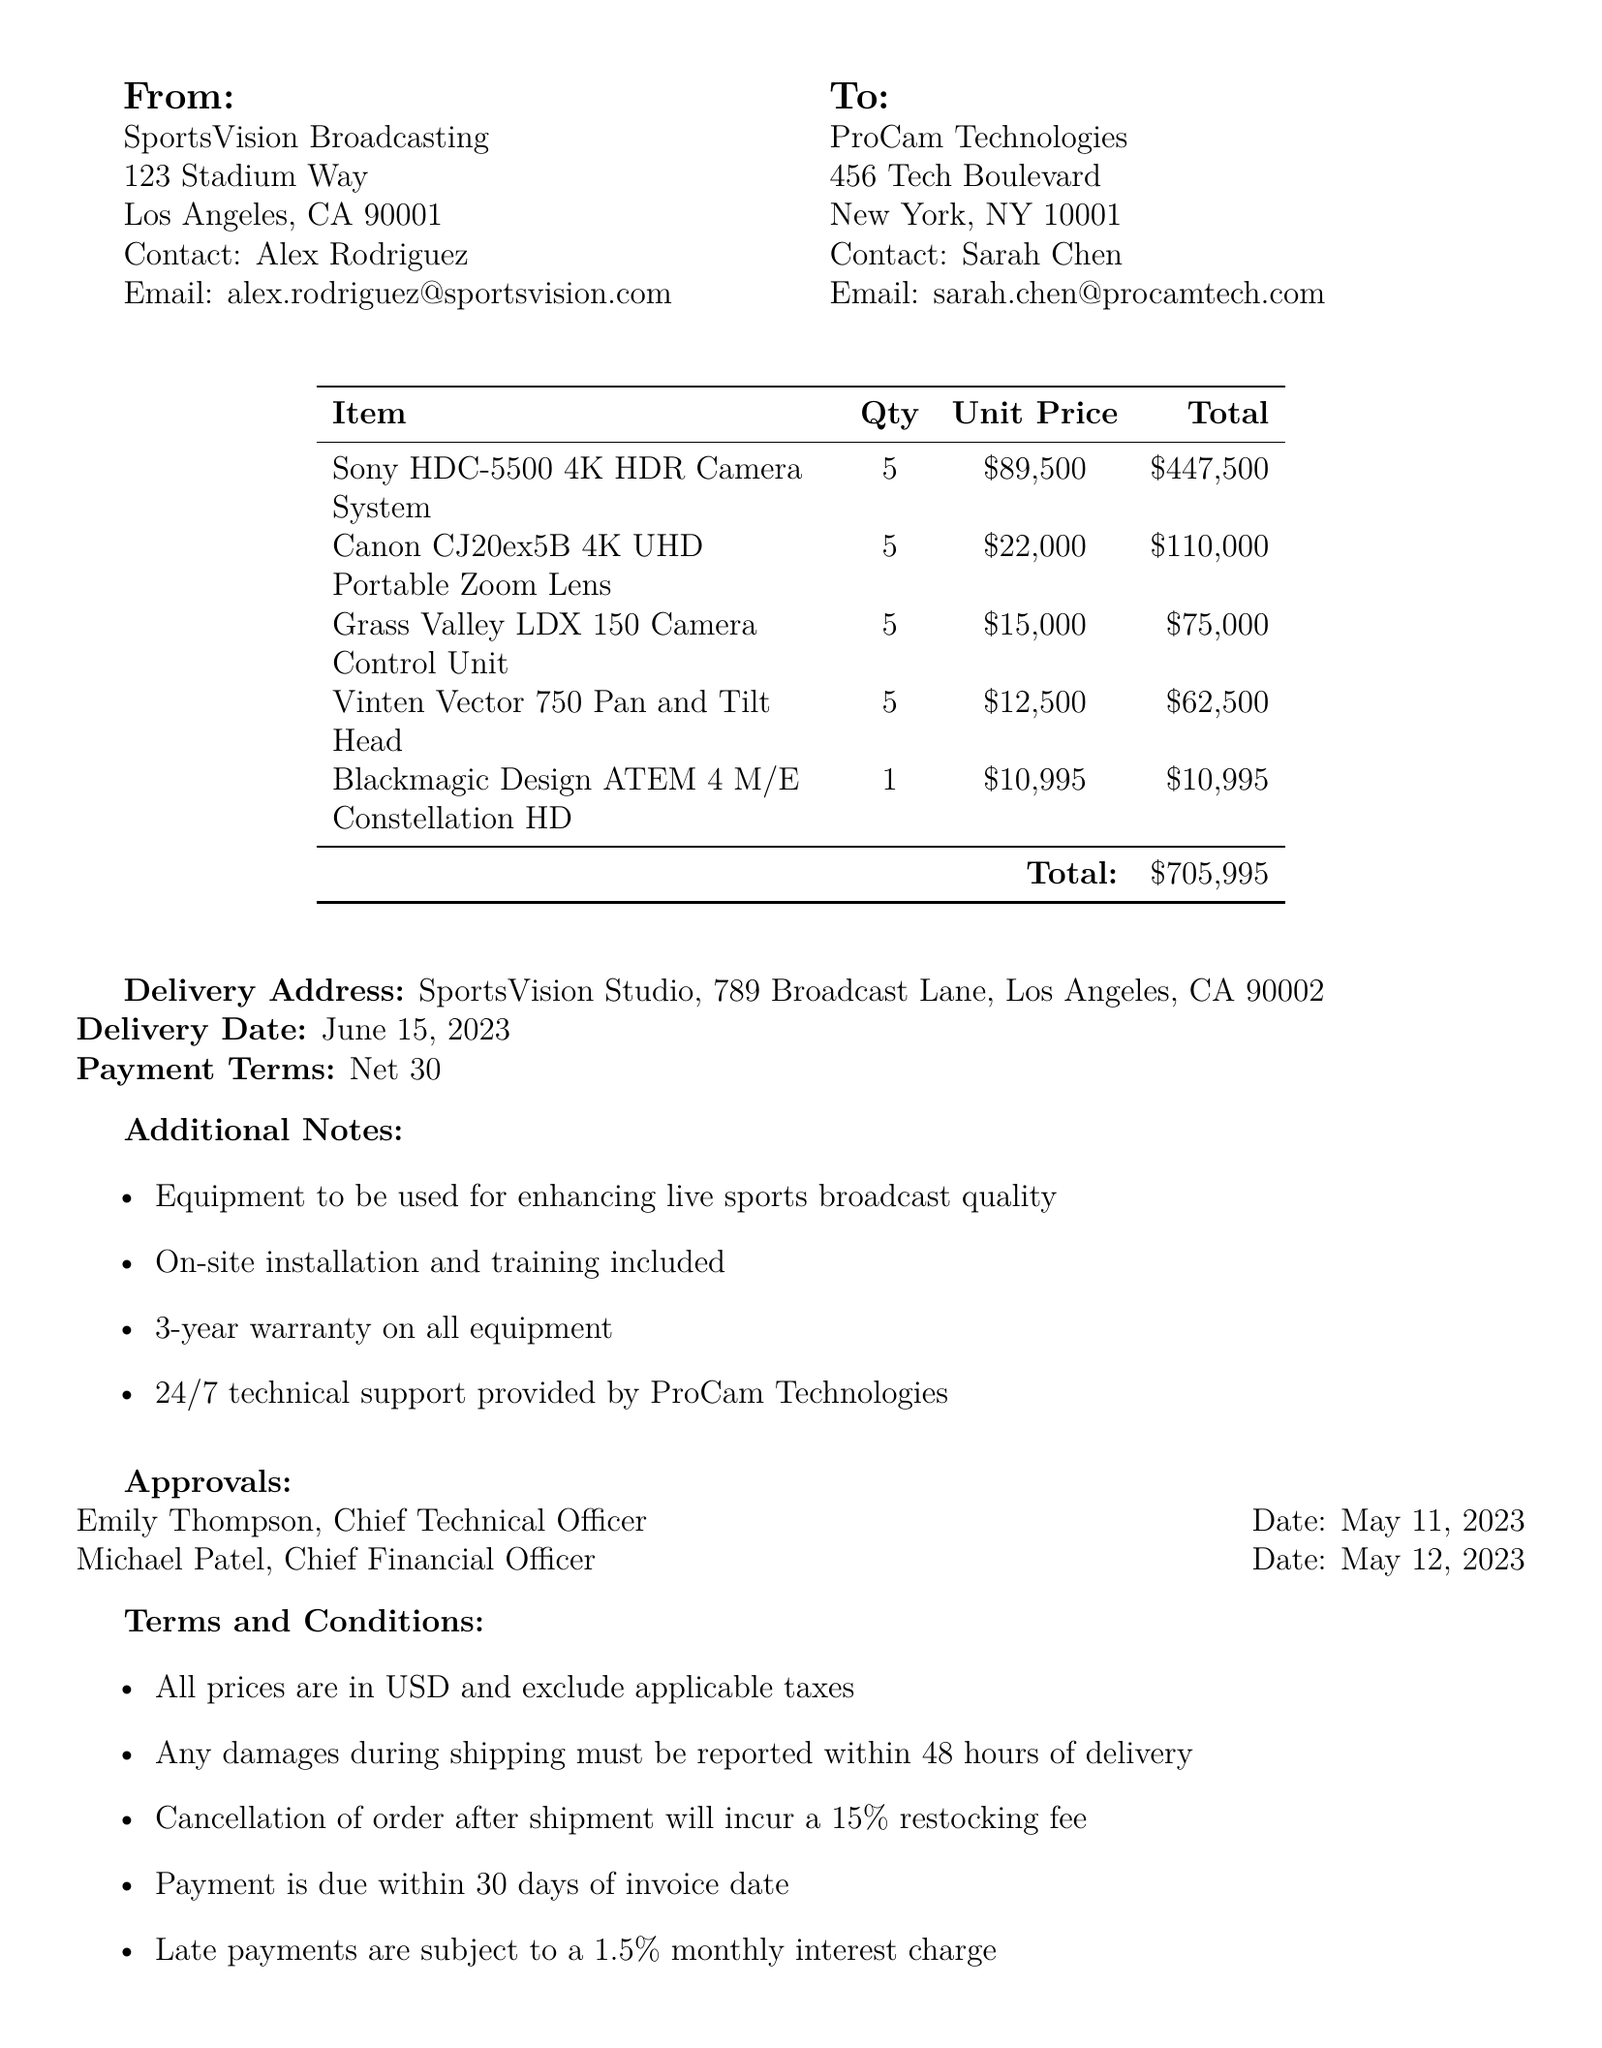what is the purchase order number? The purchase order number is explicitly listed in the document for reference purposes.
Answer: PO-2023-0512 who is the buyer? The document identifies SportsVision Broadcasting as the entity making the purchase.
Answer: SportsVision Broadcasting what is the total amount of the purchase order? The total amount is the overall cost of all items listed in the purchase order.
Answer: 705995 how many units of the Sony HDC-5500 4K HDR Camera System are ordered? The number of units can be found next to the corresponding item in the list.
Answer: 5 who is the contact person for the supplier? The contact person for the supplier is stated clearly in the supplier's section.
Answer: Sarah Chen when is the delivery date scheduled? The delivery date is specified in the document and is essential for scheduling purposes.
Answer: 2023-06-15 what is included with the purchase regarding equipment support? The document notes specific support services provided with the purchased equipment.
Answer: 24/7 technical support provided by ProCam Technologies what are the payment terms stated in the document? Payment terms outline when payment is due following the receipt of the order.
Answer: Net 30 how many approvals are listed in the document? The number of approvals can be deduced by counting the entries in the approvals section.
Answer: 2 